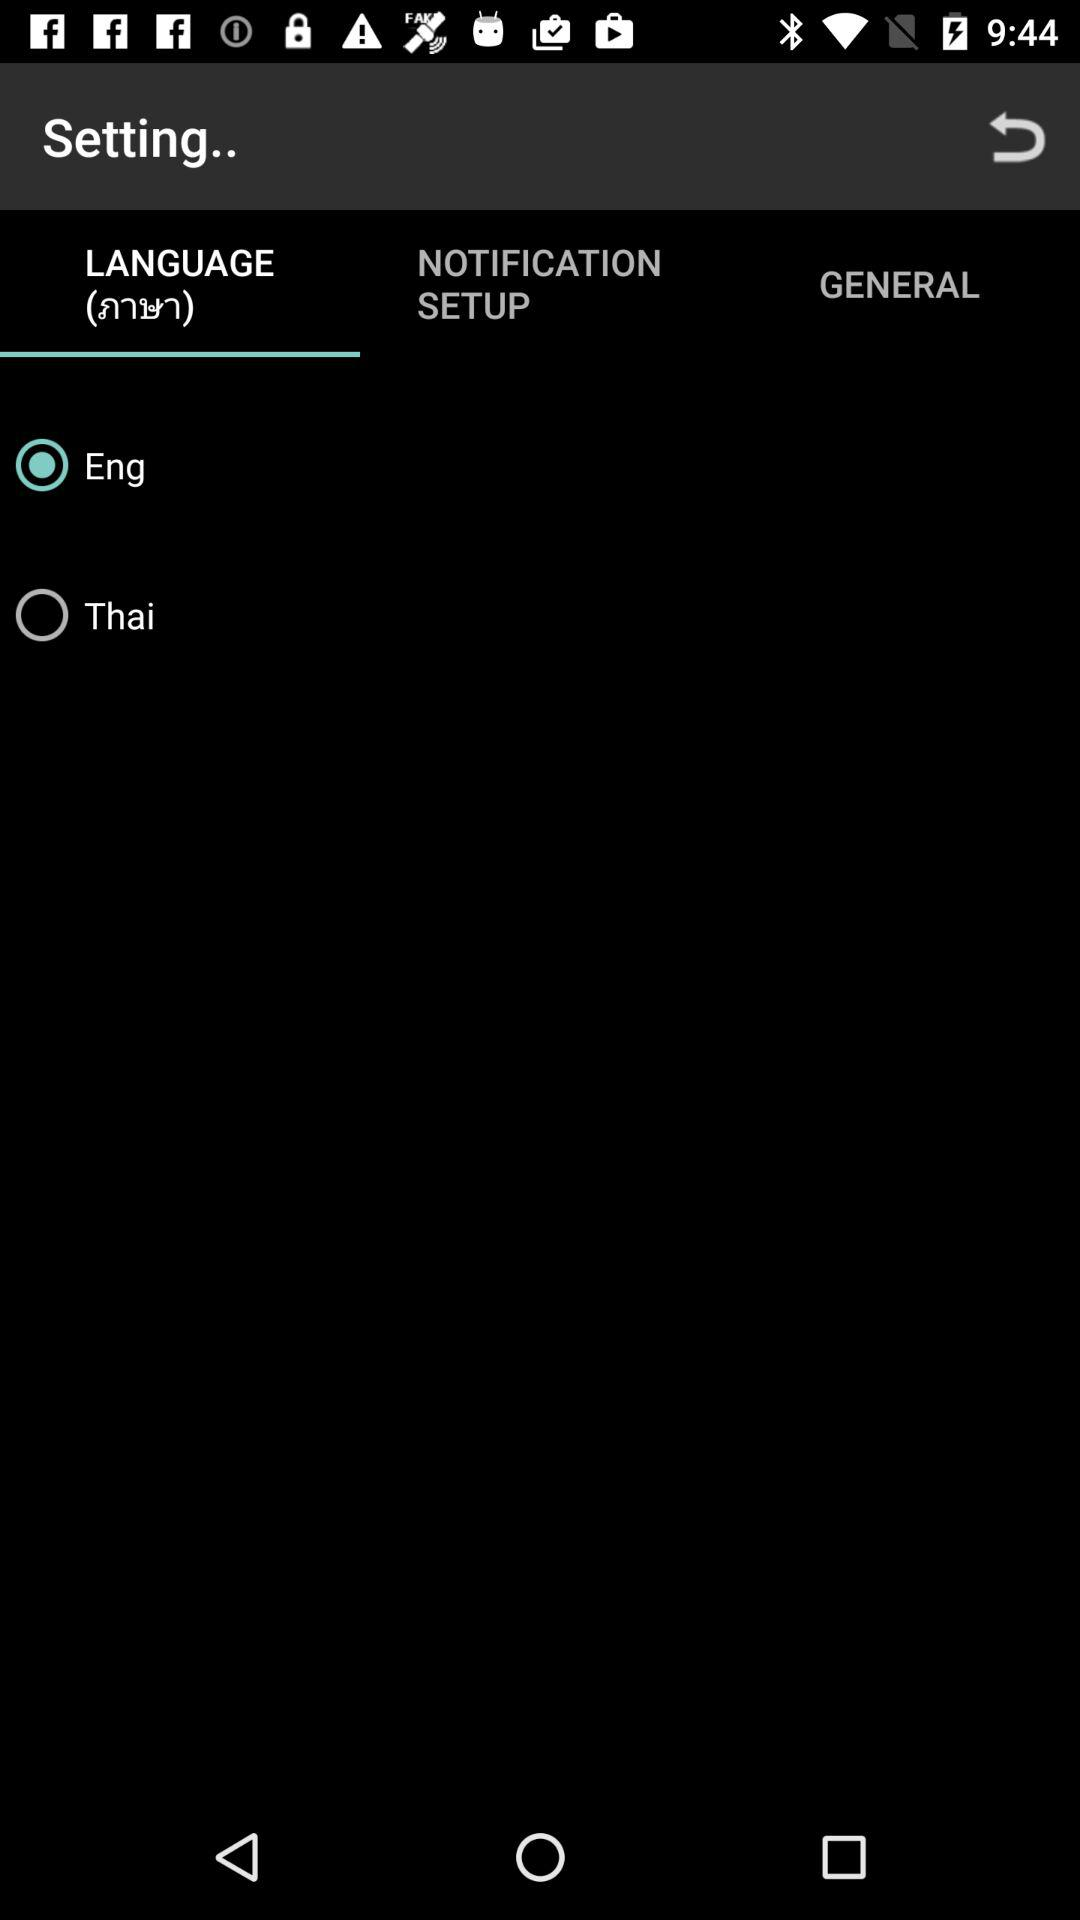How many languages can I choose from?
Answer the question using a single word or phrase. 2 